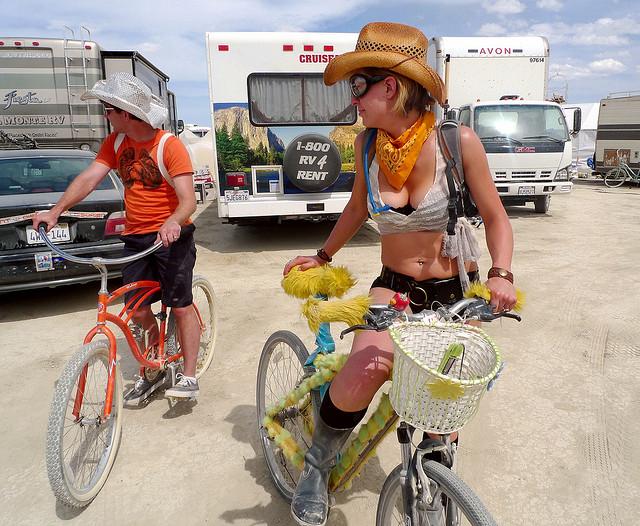What material is the seat on bike with the basket?
Answer briefly. Fur. What is on the front of the girl's bike?
Give a very brief answer. Basket. Is the girl dressed for carnival?
Keep it brief. Yes. 